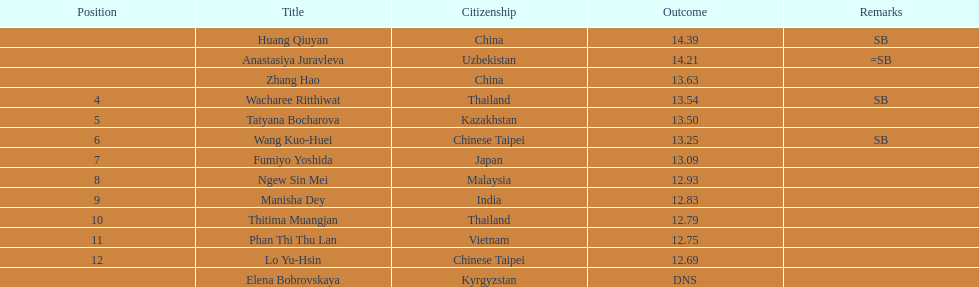Which country had the most competitors ranked in the top three in the event? China. 